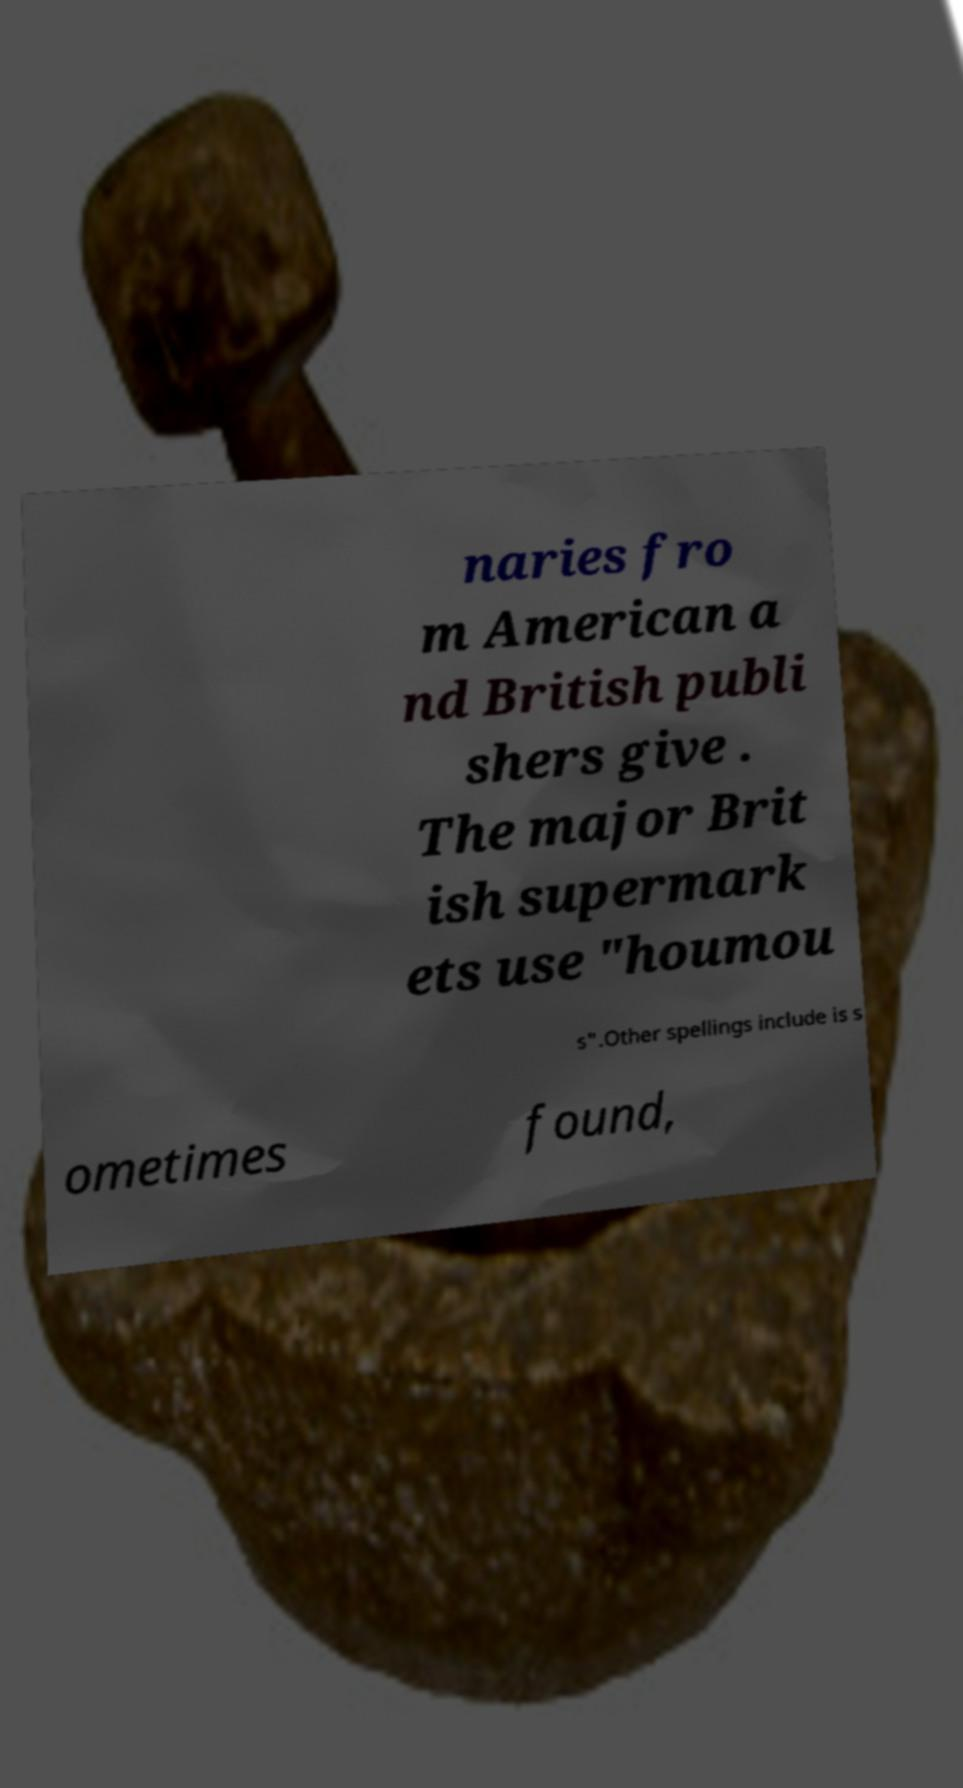Could you extract and type out the text from this image? naries fro m American a nd British publi shers give . The major Brit ish supermark ets use "houmou s".Other spellings include is s ometimes found, 